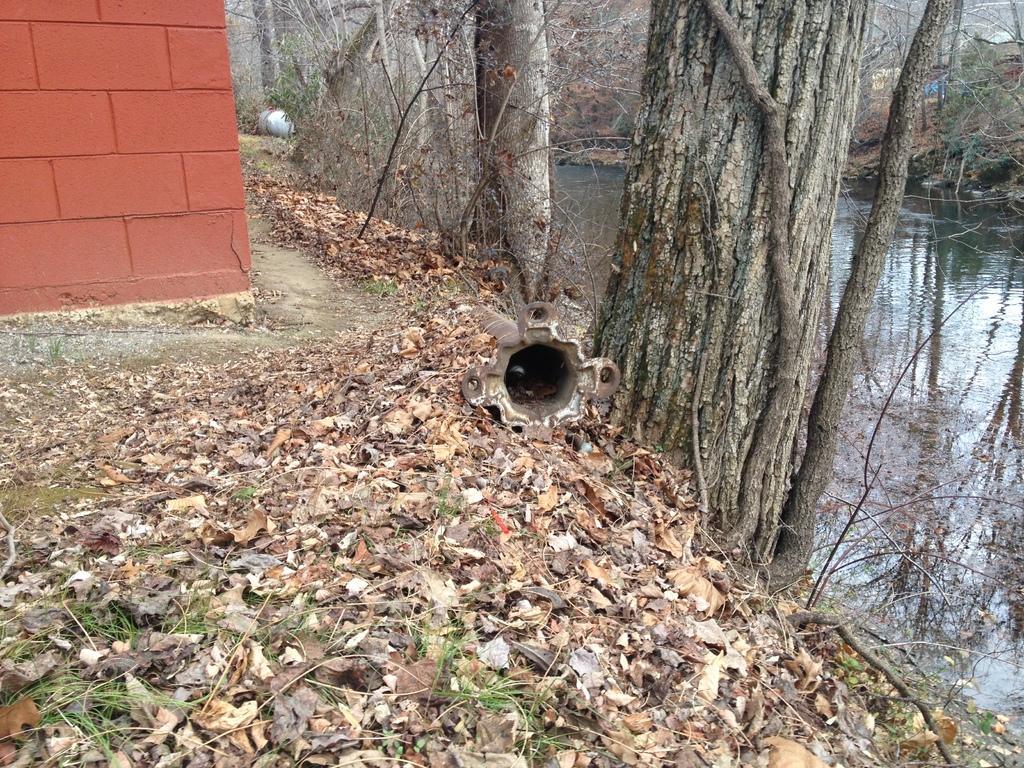How would you summarize this image in a sentence or two? The picture is taken alongside a canal. In the foreground of the picture there are dry leaves, grass and an iron pole. At the top there are dry leaves, trees, canal, grass and a canal. 